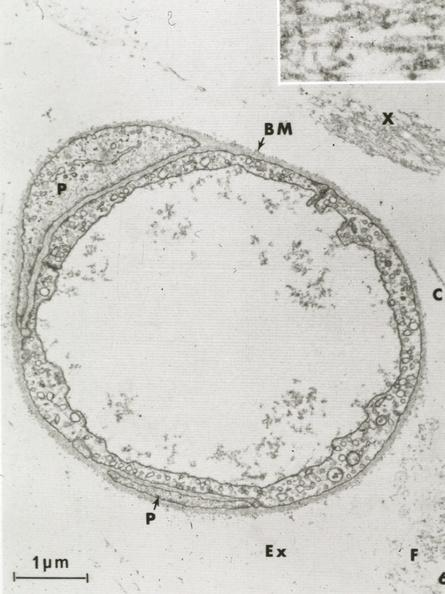s intraductal papillomatosis with apocrine metaplasia present?
Answer the question using a single word or phrase. No 